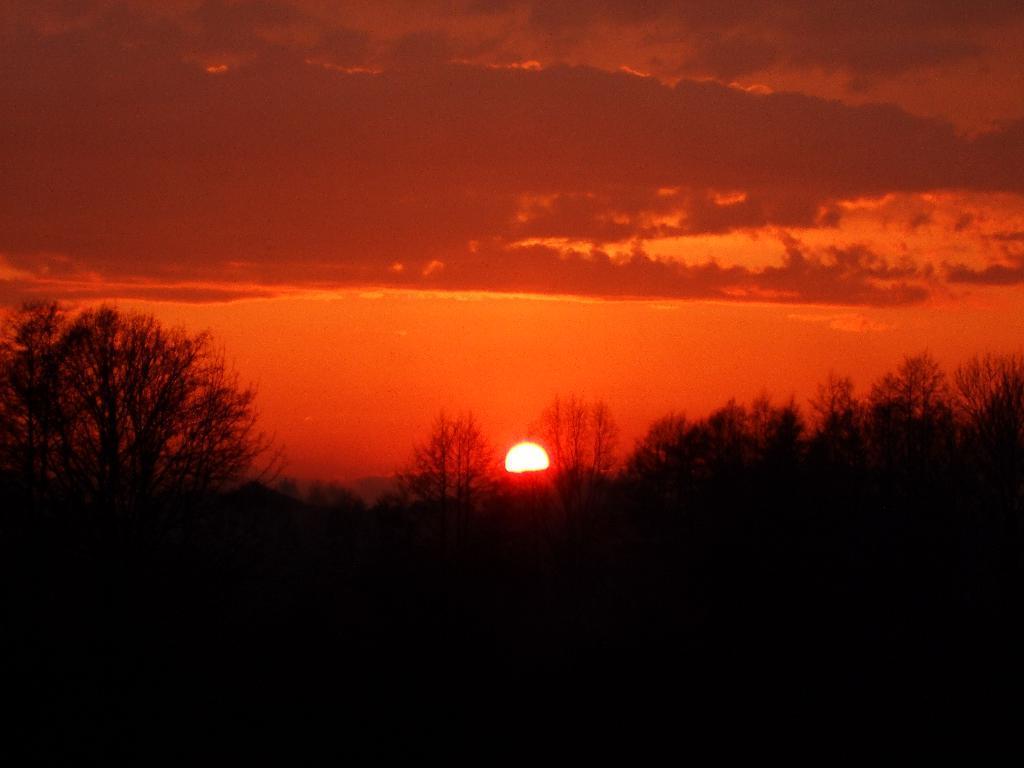Can you describe this image briefly? In this image there are some trees at bottom of this image and there is a sun in middle of this image and there is a cloudy sky at top of this image. 